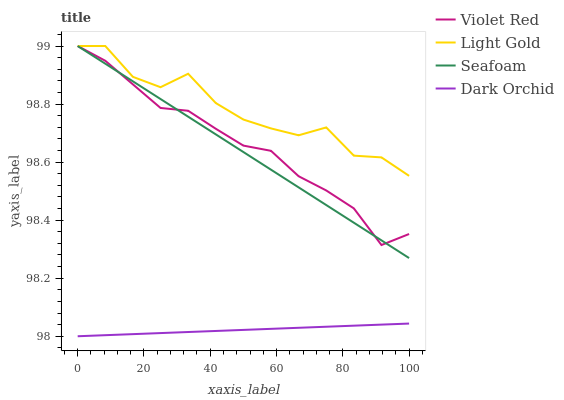Does Dark Orchid have the minimum area under the curve?
Answer yes or no. Yes. Does Light Gold have the maximum area under the curve?
Answer yes or no. Yes. Does Seafoam have the minimum area under the curve?
Answer yes or no. No. Does Seafoam have the maximum area under the curve?
Answer yes or no. No. Is Seafoam the smoothest?
Answer yes or no. Yes. Is Light Gold the roughest?
Answer yes or no. Yes. Is Light Gold the smoothest?
Answer yes or no. No. Is Seafoam the roughest?
Answer yes or no. No. Does Dark Orchid have the lowest value?
Answer yes or no. Yes. Does Seafoam have the lowest value?
Answer yes or no. No. Does Seafoam have the highest value?
Answer yes or no. Yes. Does Dark Orchid have the highest value?
Answer yes or no. No. Is Dark Orchid less than Seafoam?
Answer yes or no. Yes. Is Violet Red greater than Dark Orchid?
Answer yes or no. Yes. Does Violet Red intersect Seafoam?
Answer yes or no. Yes. Is Violet Red less than Seafoam?
Answer yes or no. No. Is Violet Red greater than Seafoam?
Answer yes or no. No. Does Dark Orchid intersect Seafoam?
Answer yes or no. No. 